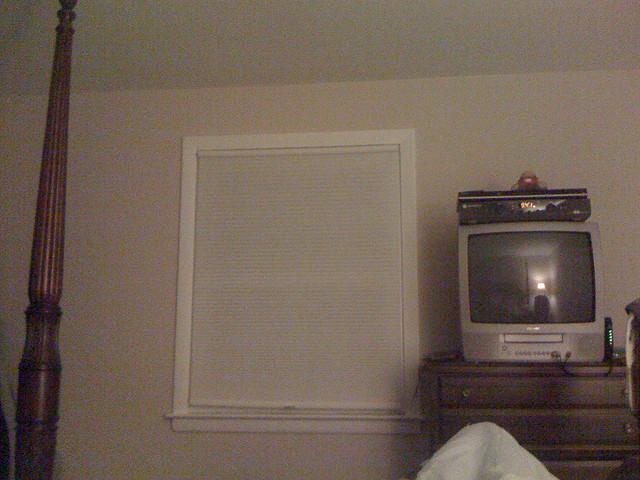What type of room is pictured?
Give a very brief answer. Bedroom. Where is the TV?
Quick response, please. Dresser. Is there a cat in the house?
Quick response, please. No. What is the object hanging from the window?
Give a very brief answer. Blinds. Is the TV on?
Answer briefly. No. What year was this picture taken?
Concise answer only. 2010. Is the monitor on?
Quick response, please. No. Is the television screen on?
Write a very short answer. No. What is the TV sitting on?
Concise answer only. Dresser. How many windows are there?
Be succinct. 1. What is on top of the TV?
Be succinct. Vcr. What time is this?
Short answer required. Night. 